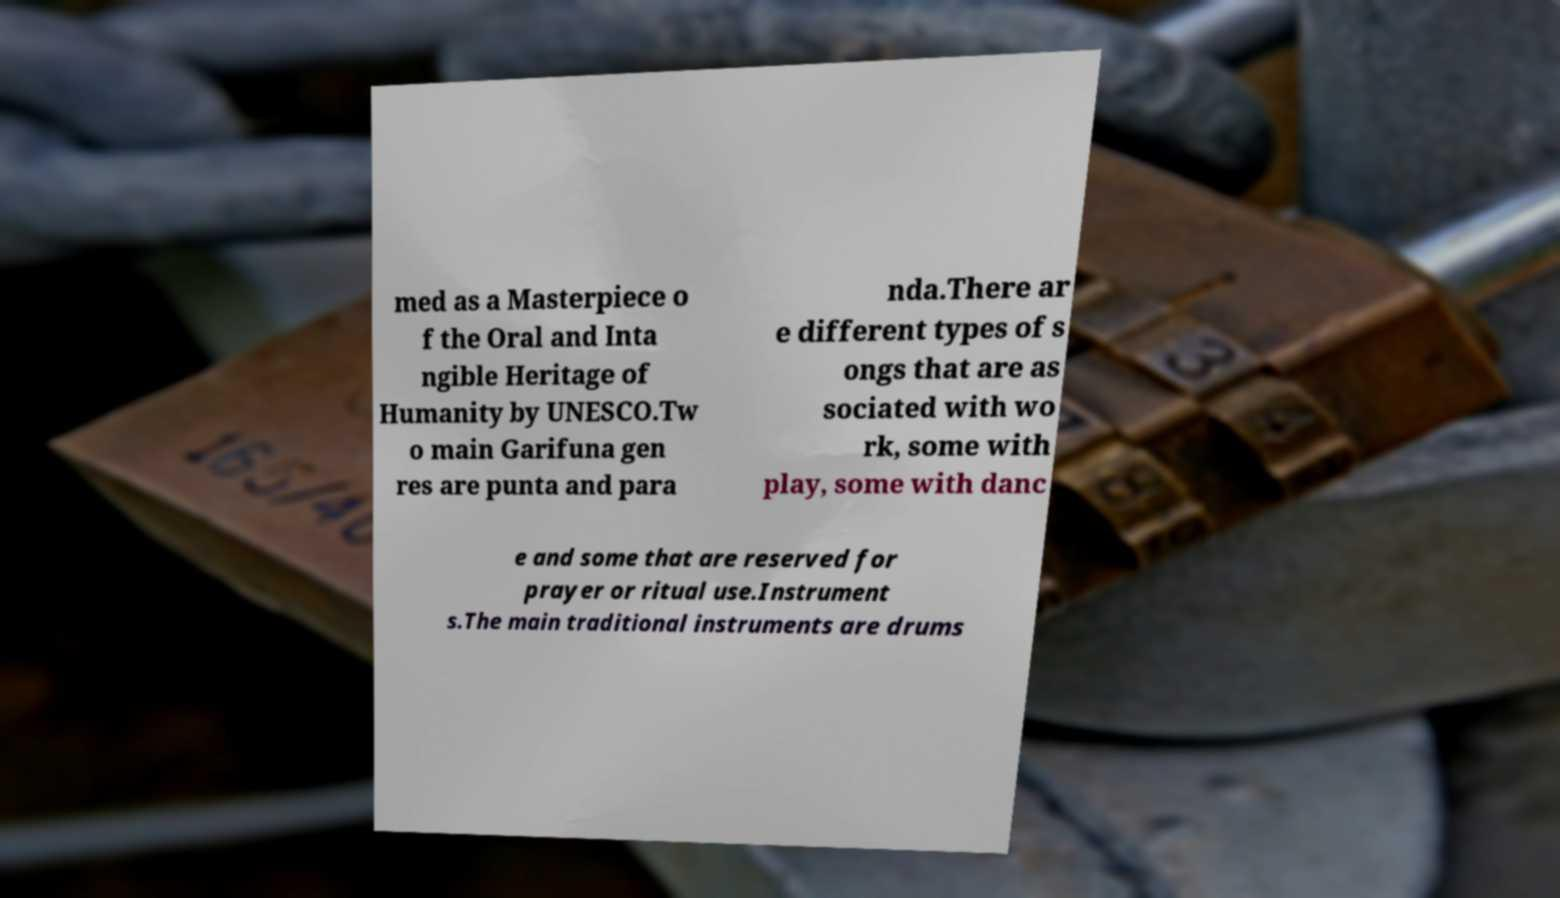Please identify and transcribe the text found in this image. med as a Masterpiece o f the Oral and Inta ngible Heritage of Humanity by UNESCO.Tw o main Garifuna gen res are punta and para nda.There ar e different types of s ongs that are as sociated with wo rk, some with play, some with danc e and some that are reserved for prayer or ritual use.Instrument s.The main traditional instruments are drums 